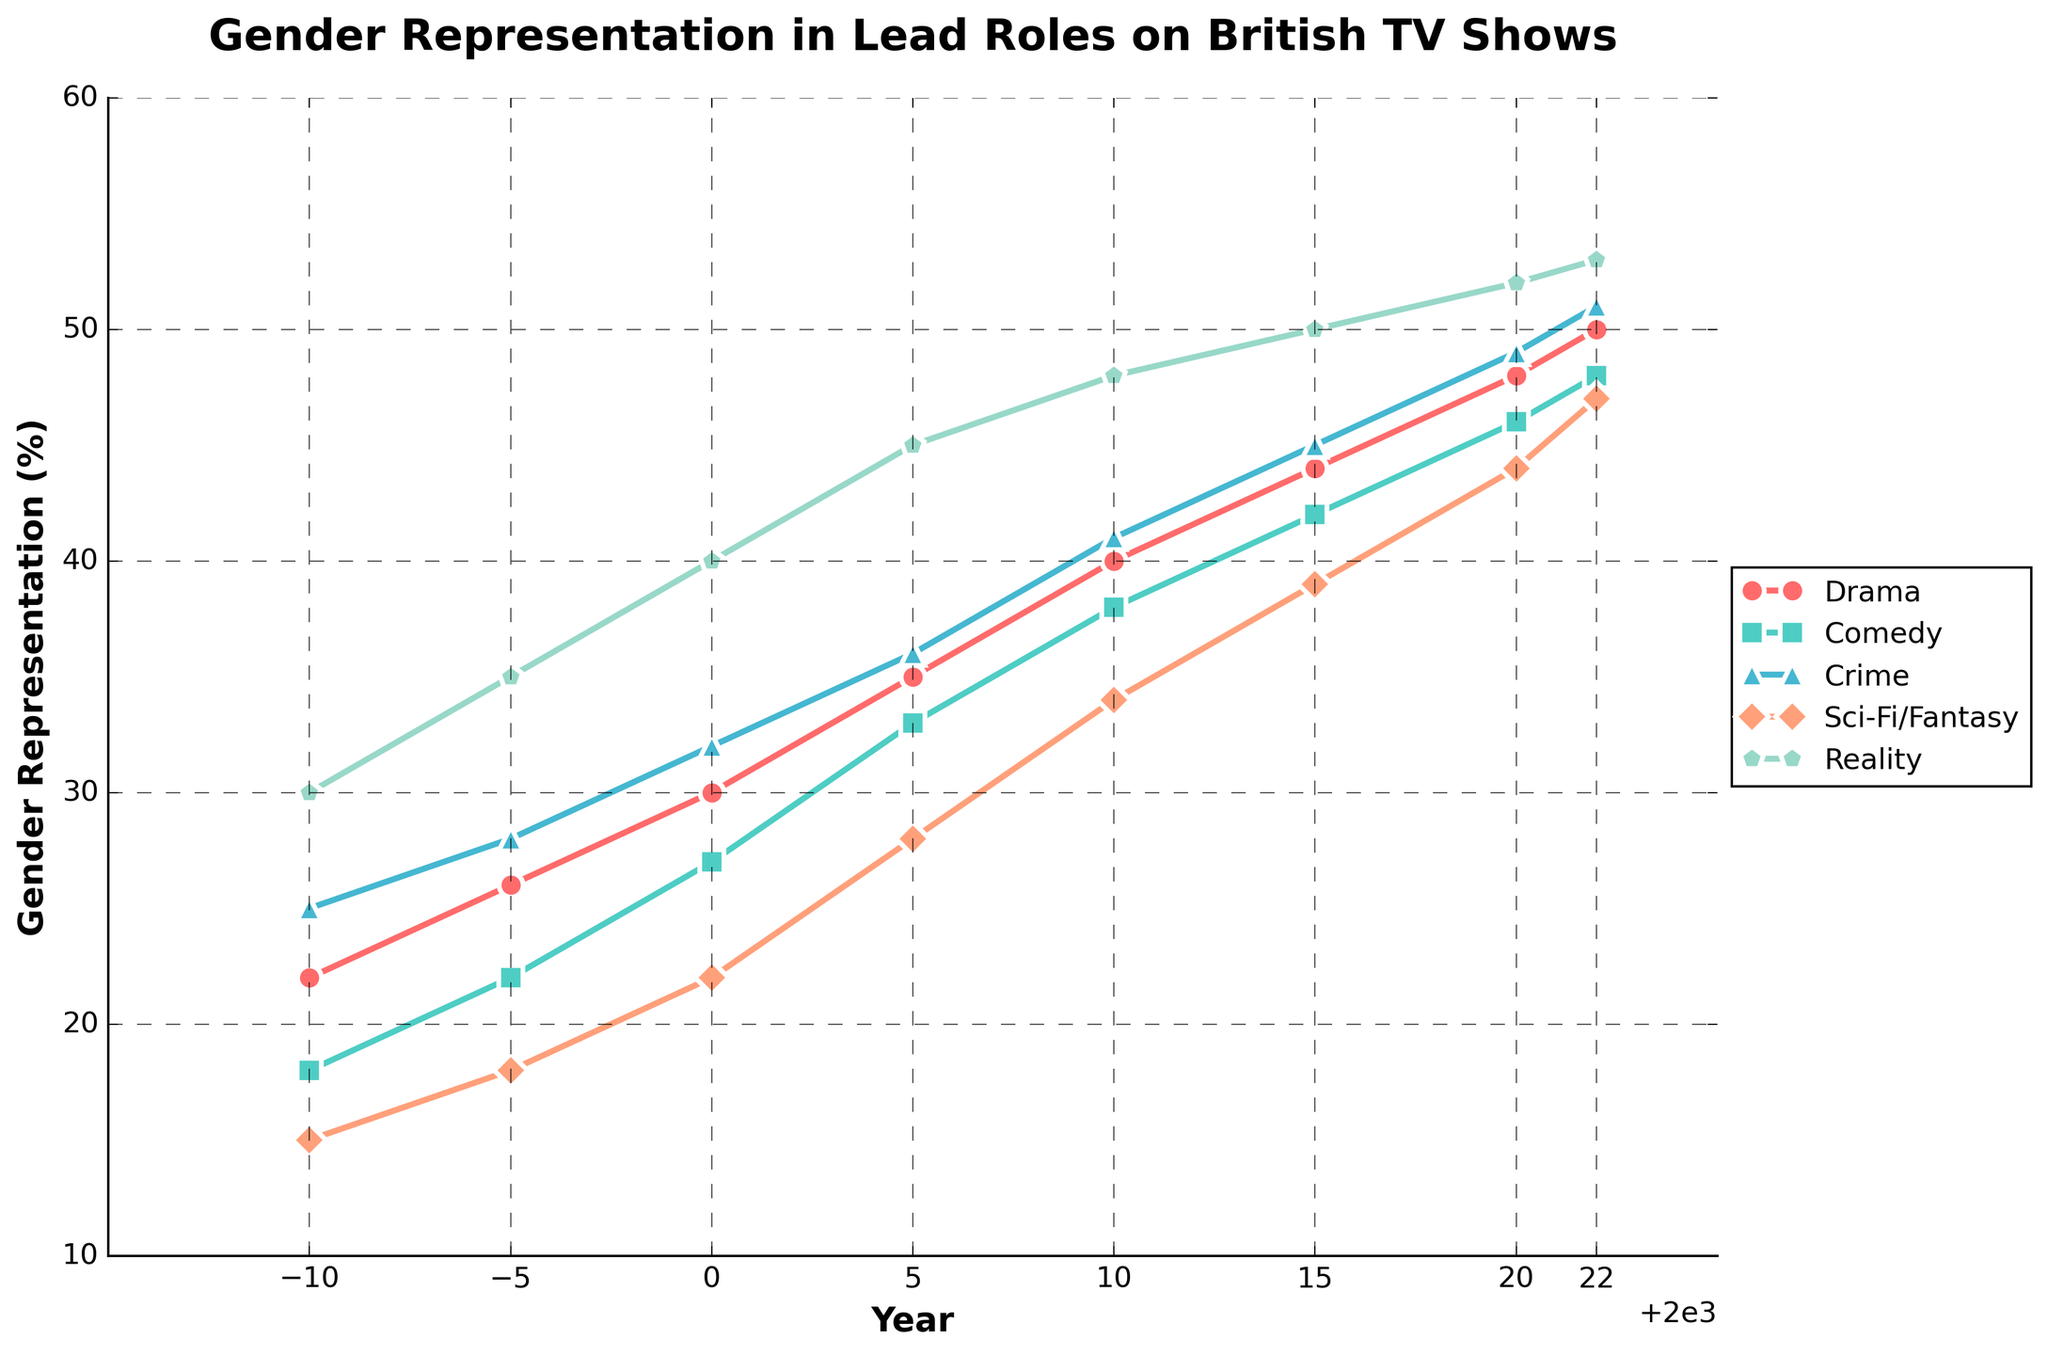What's the percentage of gender representation in lead roles for Drama in 2000? Look for the data point in the Drama line in the year 2000. It's the y-coordinate of the corresponding marker.
Answer: 30 Which genre showed the highest gender representation in 2022? Compare the y-coordinates of each genre in the year 2022. The genre with the highest y-coordinate is the answer.
Answer: Reality Between which two successive years did Sci-Fi/Fantasy show the largest increase in gender representation? Calculate the difference in percentages for Sci-Fi/Fantasy between each pair of successive years. Find the pair with the largest difference.
Answer: 2000 to 2005 Has Comedy ever had a higher gender representation than Drama at any point? Compare the y-coordinates of Comedy and Drama in all given years. Identify any year where Comedy's y-coordinate is greater than Drama's.
Answer: No By how much did the percentage of gender representation in lead roles for Crime increase from 1990 to 2020? Subtract the 1990 percentage of Crime from the 2020 percentage of Crime.
Answer: 24 What is the average gender representation for Reality shows from 2000 to 2022? Add the percentages for Reality in each specified year (2000, 2005, 2010, 2015, 2020, 2022) and divide by the number of years.
Answer: 48 Which genre had the smallest increase in gender representation between 2015 and 2020? Calculate the difference in percentages between 2015 and 2020 for each genre. Identify the genre with the smallest difference.
Answer: Reality In which year did Drama and Comedy have the same percentage of gender representation in lead roles? Check the plot where the y-coordinates of Drama and Comedy intersect. If they never intersect, state that.
Answer: Never intersect What was the total increase in gender representation for Sci-Fi/Fantasy from 1990 to 2022? Subtract the 1990 percentage from the 2022 percentage for Sci-Fi/Fantasy.
Answer: 32 How many years did it take for the Drama genre to increase its gender representation by 20%? Identify the starting year (first data point) and find the year when the representation is 20% higher. Count the years between these two points.
Answer: 1990 to 2005, 15 years 